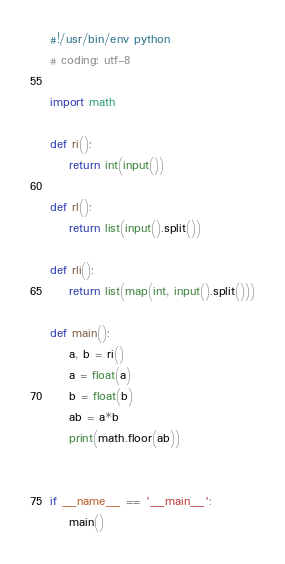Convert code to text. <code><loc_0><loc_0><loc_500><loc_500><_Python_>#!/usr/bin/env python
# coding: utf-8

import math

def ri():
    return int(input())

def rl():
    return list(input().split())

def rli():
    return list(map(int, input().split()))

def main():
    a, b = ri()
    a = float(a)
    b = float(b)
    ab = a*b
    print(math.floor(ab))


if __name__ == '__main__':
    main()
</code> 